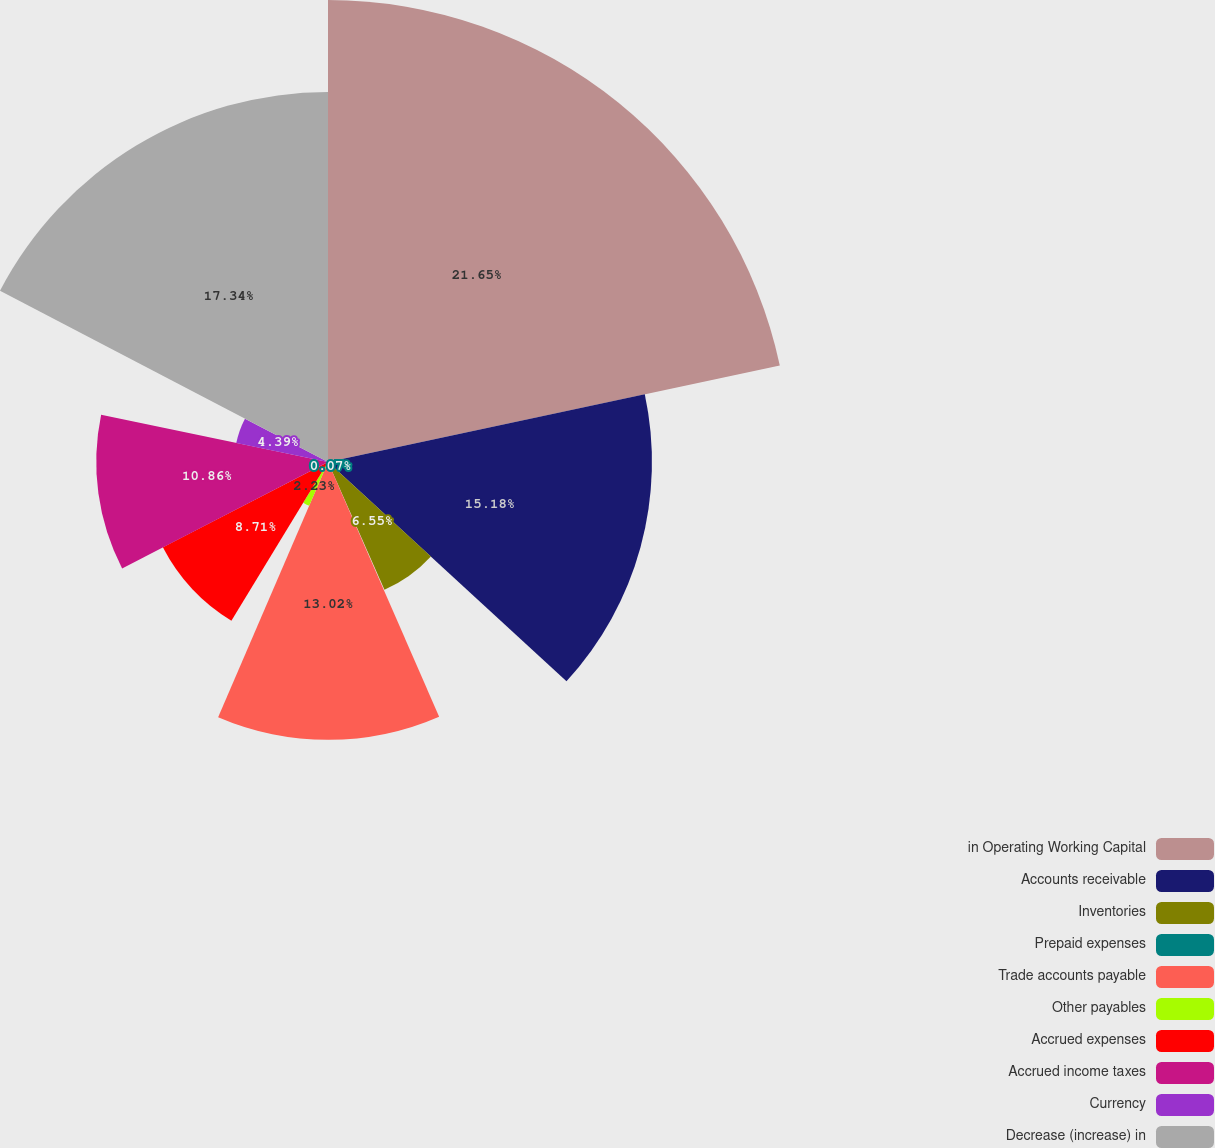Convert chart. <chart><loc_0><loc_0><loc_500><loc_500><pie_chart><fcel>in Operating Working Capital<fcel>Accounts receivable<fcel>Inventories<fcel>Prepaid expenses<fcel>Trade accounts payable<fcel>Other payables<fcel>Accrued expenses<fcel>Accrued income taxes<fcel>Currency<fcel>Decrease (increase) in<nl><fcel>21.65%<fcel>15.18%<fcel>6.55%<fcel>0.07%<fcel>13.02%<fcel>2.23%<fcel>8.71%<fcel>10.86%<fcel>4.39%<fcel>17.34%<nl></chart> 